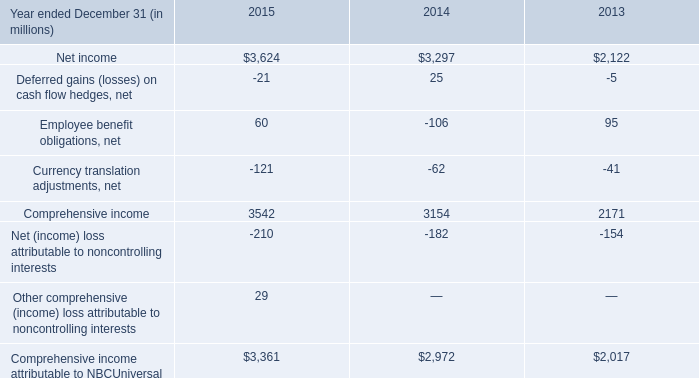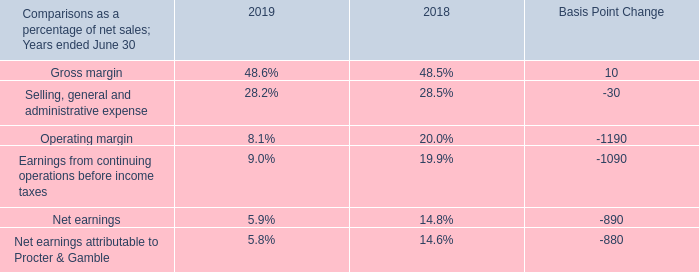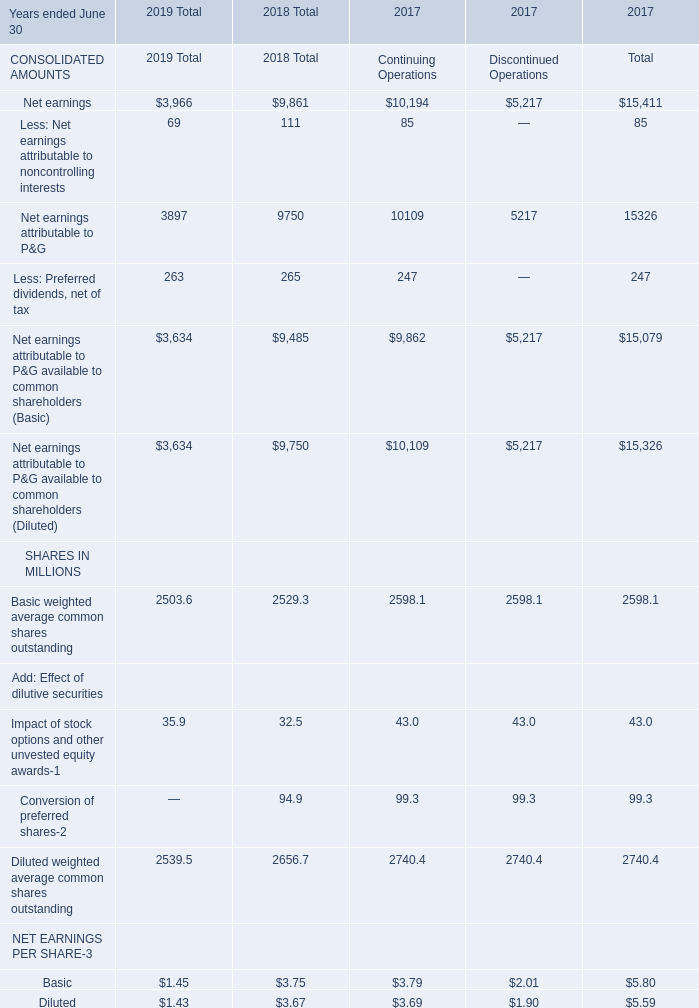In the year with the most Gross margin in Table 1, what is the growth rate of Net earnings in Table 2? 
Computations: ((3966 - 9861) / 9861)
Answer: -0.59781. 